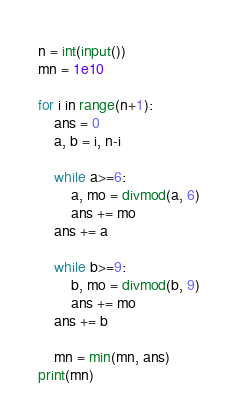<code> <loc_0><loc_0><loc_500><loc_500><_Python_>n = int(input())
mn = 1e10

for i in range(n+1):
    ans = 0
    a, b = i, n-i

    while a>=6:
        a, mo = divmod(a, 6)
        ans += mo
    ans += a

    while b>=9:
        b, mo = divmod(b, 9)
        ans += mo
    ans += b

    mn = min(mn, ans)
print(mn)</code> 